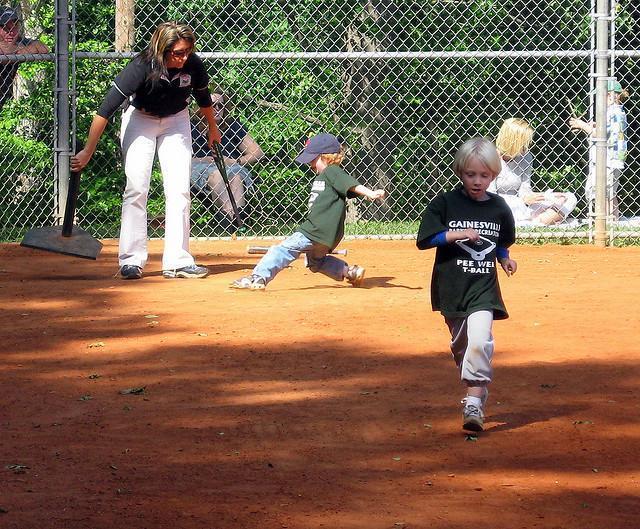How many people are in the photo?
Give a very brief answer. 6. 